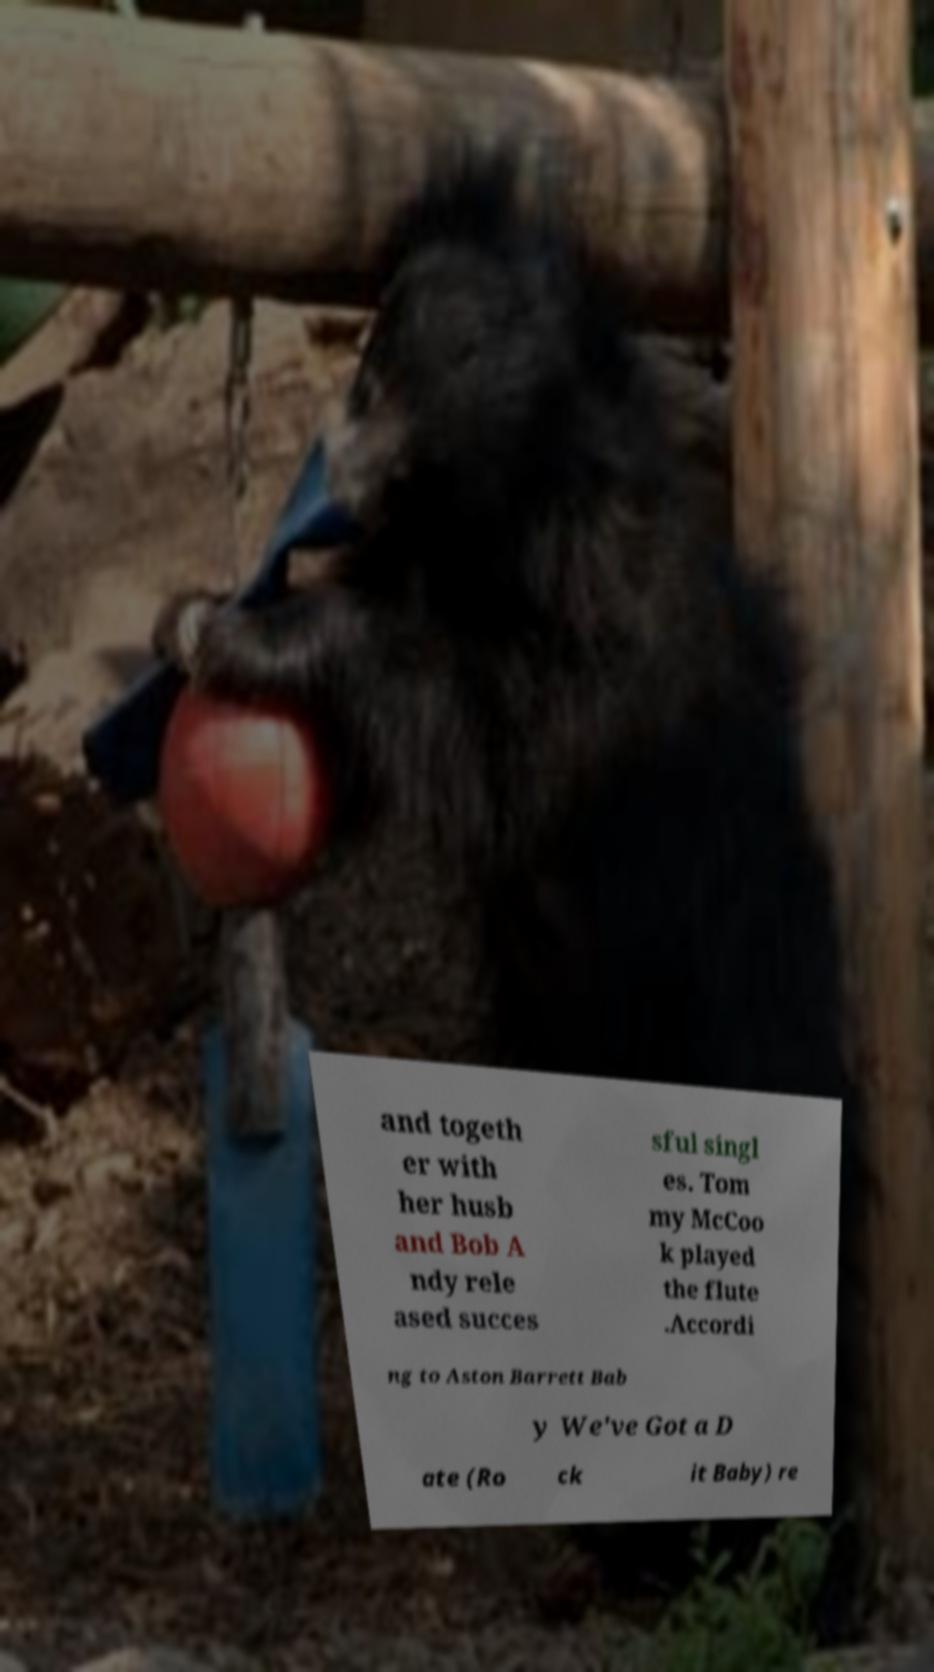Please read and relay the text visible in this image. What does it say? and togeth er with her husb and Bob A ndy rele ased succes sful singl es. Tom my McCoo k played the flute .Accordi ng to Aston Barrett Bab y We've Got a D ate (Ro ck it Baby) re 